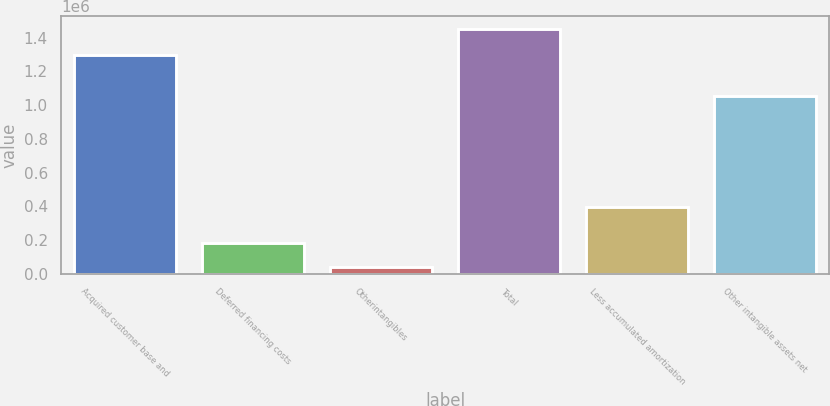Convert chart to OTSL. <chart><loc_0><loc_0><loc_500><loc_500><bar_chart><fcel>Acquired customer base and<fcel>Deferred financing costs<fcel>Otherintangibles<fcel>Total<fcel>Less accumulated amortization<fcel>Other intangible assets net<nl><fcel>1.29971e+06<fcel>184244<fcel>43125<fcel>1.45432e+06<fcel>397240<fcel>1.05708e+06<nl></chart> 